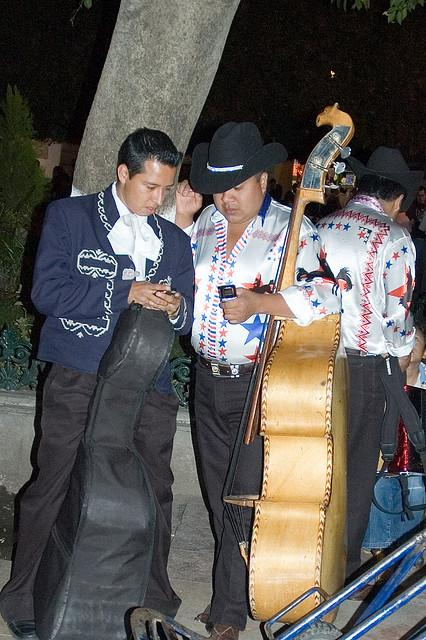What kind of music band do they play music in? mariachi 